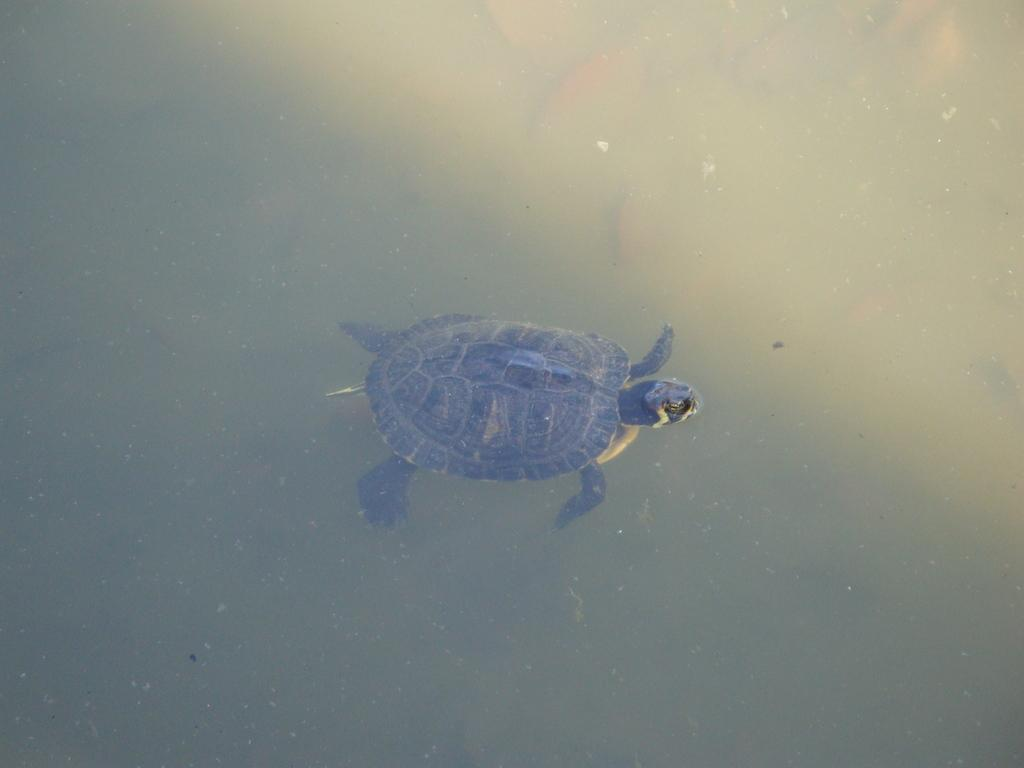What is the main subject in the center of the picture? There is a tortoise in the center of the picture. What is the tortoise's environment in the image? The tortoise is in water. Can you describe the water in the image? There is water visible in the image, and it contains some objects. What nation is the judge from in the image? There is no judge or nation present in the image; it features a tortoise in water. What type of voyage is the tortoise embarking on in the image? The tortoise is not embarking on a voyage in the image; it is simply in the water. 